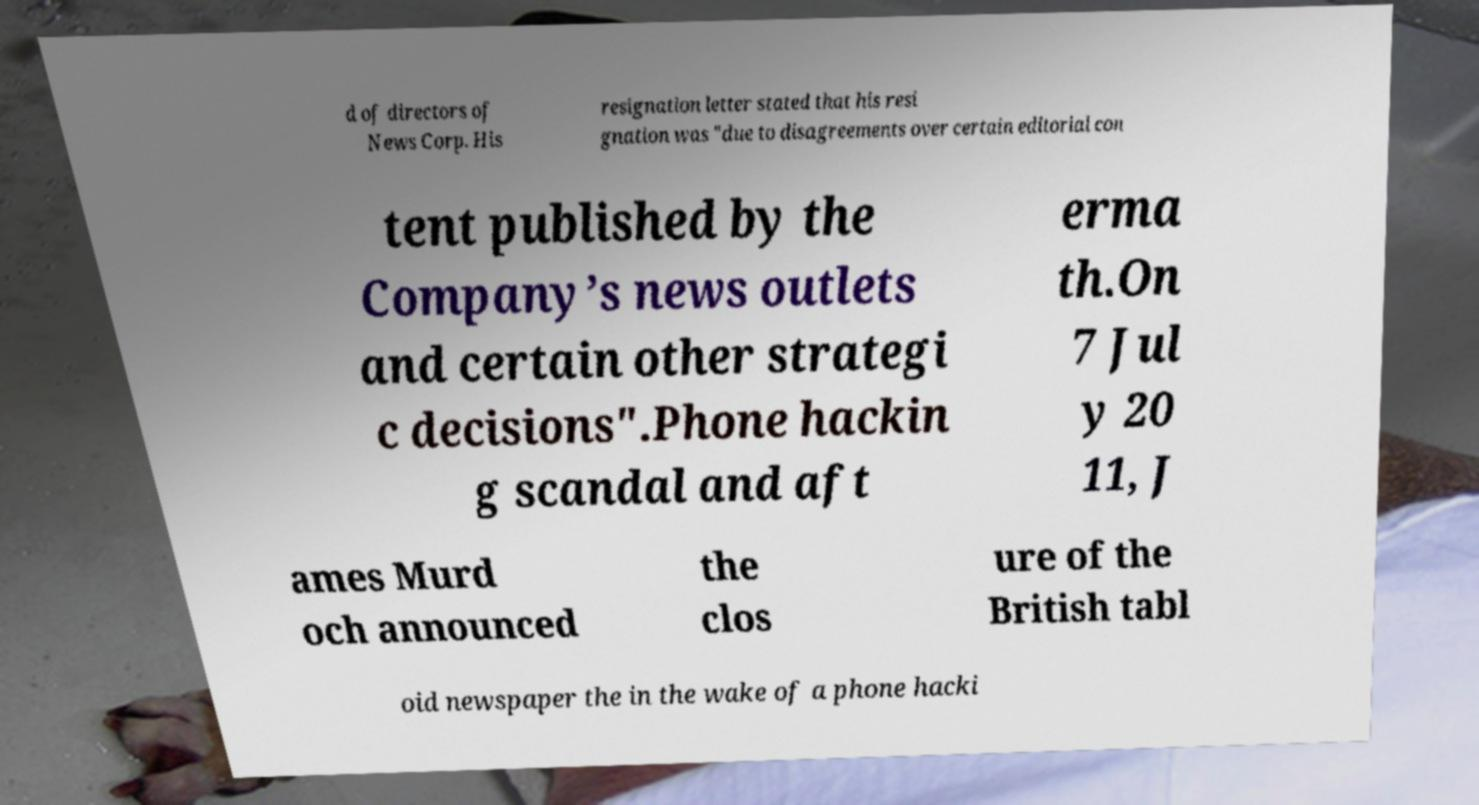What messages or text are displayed in this image? I need them in a readable, typed format. d of directors of News Corp. His resignation letter stated that his resi gnation was "due to disagreements over certain editorial con tent published by the Company’s news outlets and certain other strategi c decisions".Phone hackin g scandal and aft erma th.On 7 Jul y 20 11, J ames Murd och announced the clos ure of the British tabl oid newspaper the in the wake of a phone hacki 